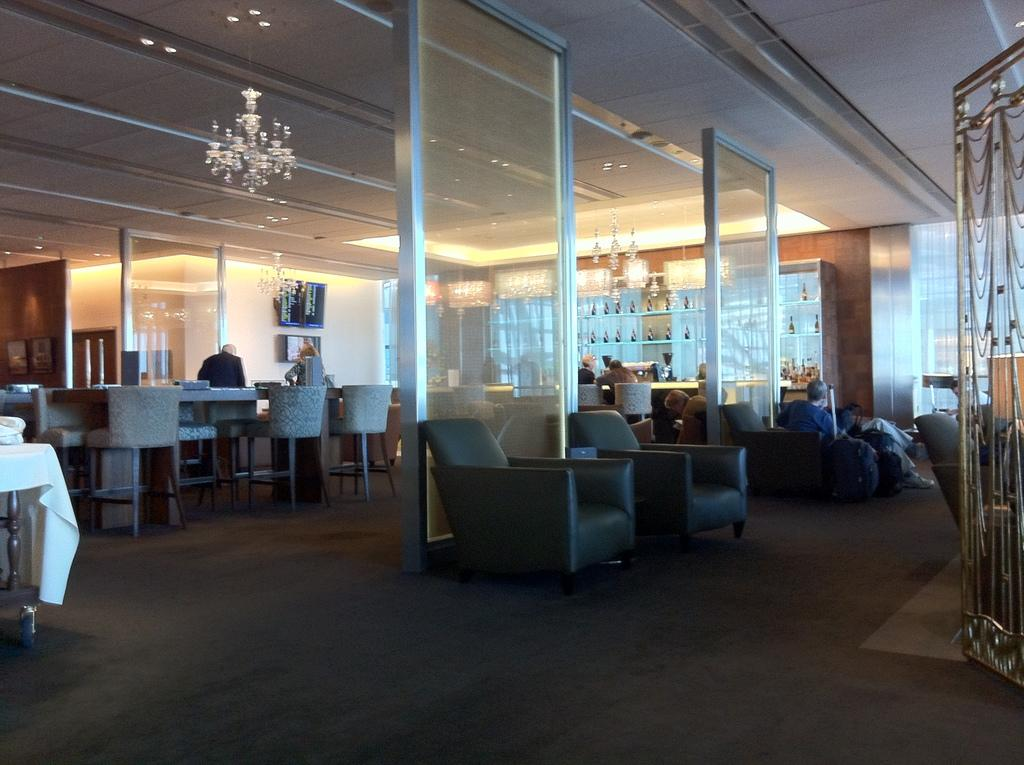What type of furniture is present in the image? There are chairs and tables in the image. What are the people in the image doing? There are people seated on the chairs in the image. What can be used for illumination in the image? There are lights visible in the image. What type of electronic device is present in the image? There is a television in the image. What type of medical advice is the doctor giving in the image? There is no doctor present in the image, so no medical advice can be given. 